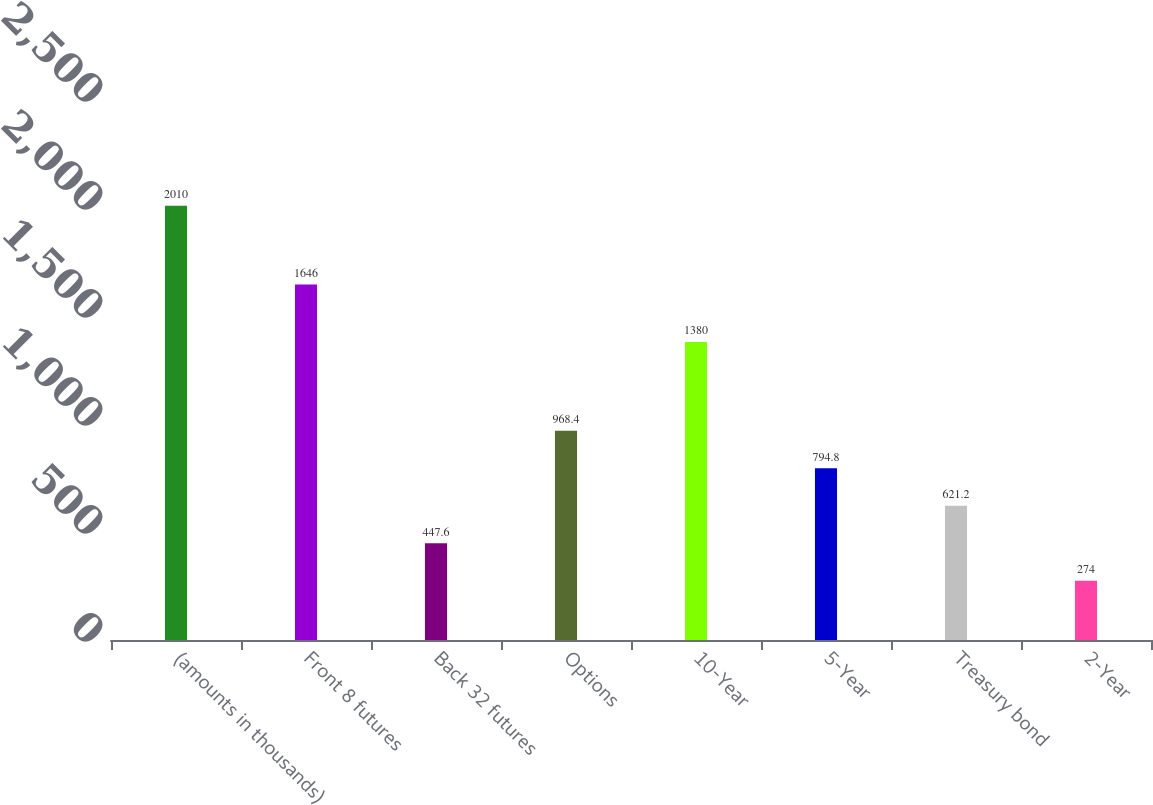Convert chart to OTSL. <chart><loc_0><loc_0><loc_500><loc_500><bar_chart><fcel>(amounts in thousands)<fcel>Front 8 futures<fcel>Back 32 futures<fcel>Options<fcel>10-Year<fcel>5-Year<fcel>Treasury bond<fcel>2-Year<nl><fcel>2010<fcel>1646<fcel>447.6<fcel>968.4<fcel>1380<fcel>794.8<fcel>621.2<fcel>274<nl></chart> 